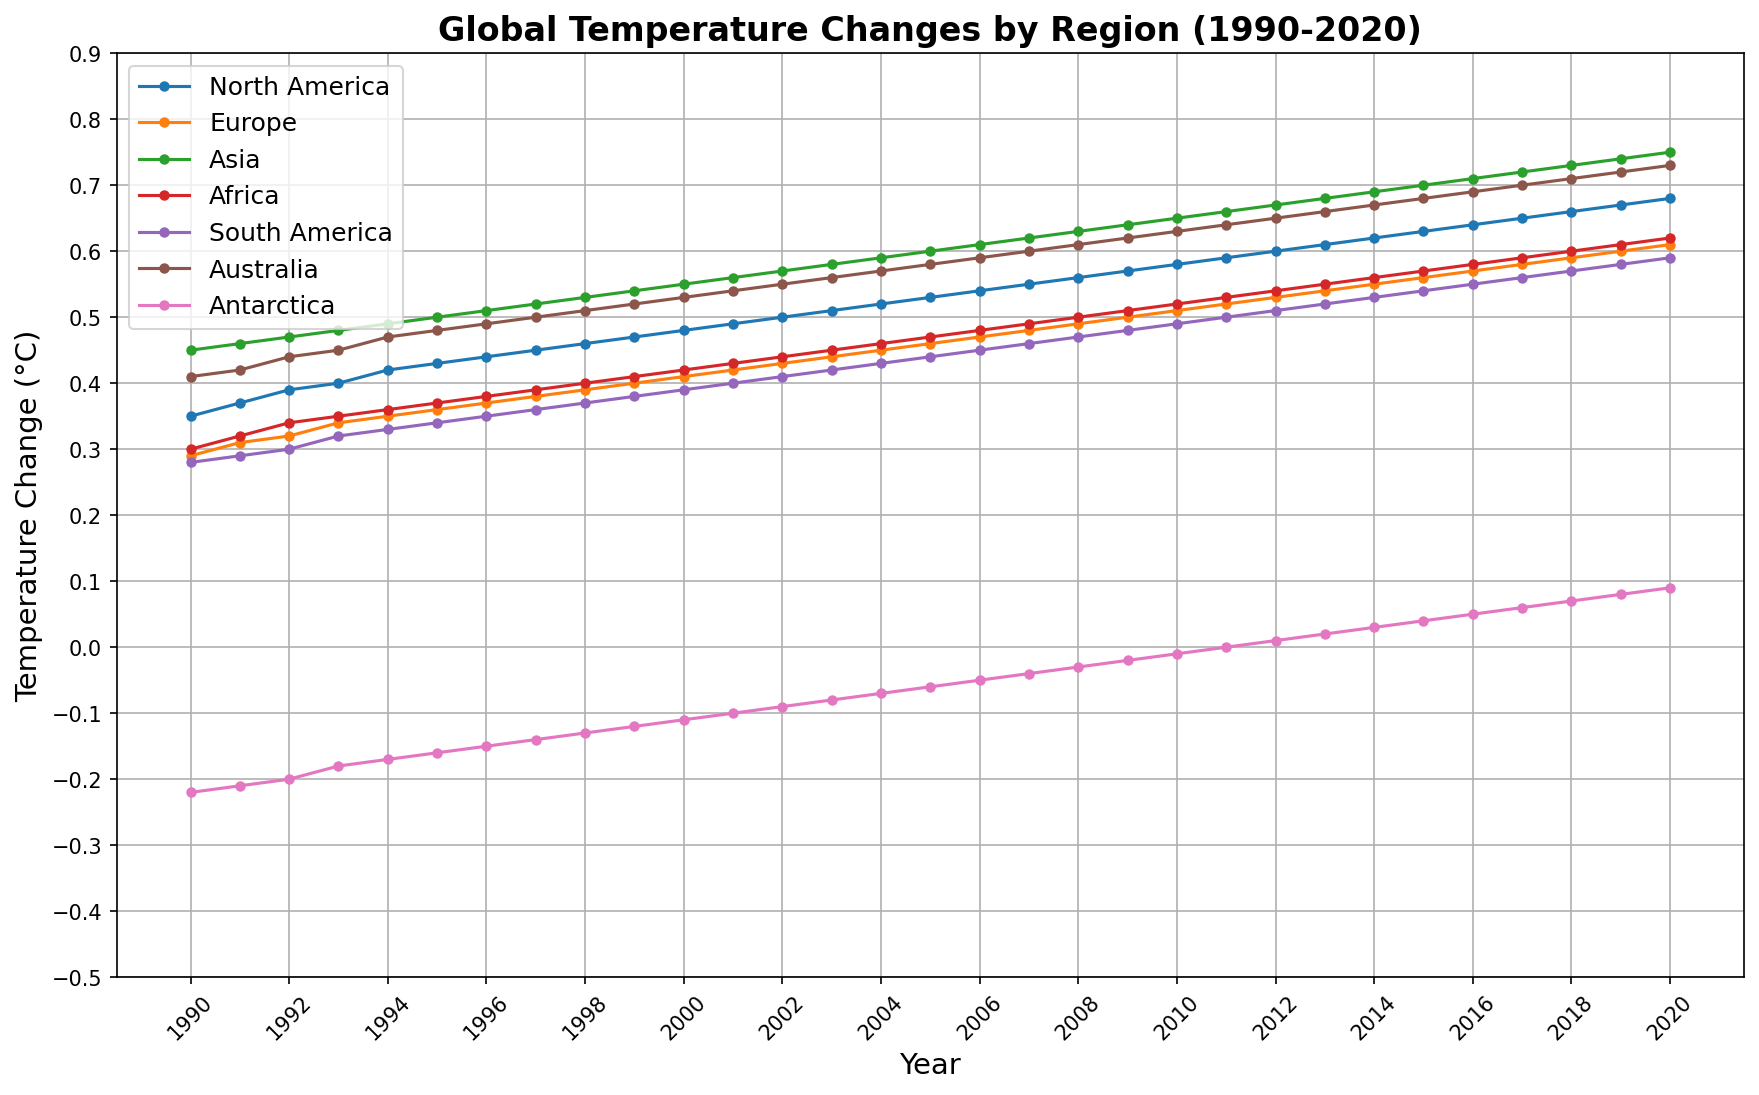What region experienced the greatest temperature change in 2020? To determine the region with the greatest temperature change, observe the data points for each region in 2020. The region with the highest data point will represent the greatest temperature change. In the plot, Asia in 2020 has the highest temperature change at 0.75°C.
Answer: Asia Which regions had a negative temperature change in 1990? To find the regions with a negative temperature change in 1990, look for data points below the zero line for that year. In 1990, Antarctica shows a negative temperature change at -0.22°C.
Answer: Antarctica Which region saw the most consistent increase in temperature from 1990 to 2020? To identify the region with the most consistent increase, observe the trend lines for each region from 1990 to 2020. The region with a consistently upward trend is Asia, which shows a steady increase in temperature change over the years.
Answer: Asia What is the difference in temperature change between North America and Europe in 2000? To find the difference between North America and Europe's temperature changes in 2000, subtract Europe's value from North America's. North America's value is 0.48°C, and Europe's is 0.41°C. The difference is 0.48 - 0.41 = 0.07°C.
Answer: 0.07°C Which year did Antarctica show a positive temperature change for the first time? To find the first year Antarctica shows a positive temperature change, look at its data points from 1990 to 2020. Antarctica reaches a positive value for the first time in 2011 with a change of 0.00°C.
Answer: 2011 Calculate the average temperature change for South America from 1990 to 2000. To calculate the average temperature change for South America from 1990 to 2000, sum the values and divide by the number of years. Sum: 0.28+0.29+0.30+0.32+0.33+0.34+0.35+0.36+0.37+0.38+0.39 = 3.71. Divide by the number of years: 3.71/11 ≈ 0.34°C.
Answer: 0.34°C Which region had the smallest temperature change in 1998? To find the smallest temperature change in 1998, compare the data points for all regions. Antarctica shows the smallest change with a value of -0.13°C.
Answer: Antarctica Which year saw the largest increase in temperature change for Africa compared to the previous year? To determine the year with the largest increase, calculate the yearly differences for Africa's temperature changes and find the maximum. The largest increase appears between 2007 (0.49°C) and 2008 (0.50°C), equal to 0.01°C.
Answer: 2008 In what year did Australia's temperature change exceed that of North America, and by how much? To determine when Australia's temperature change exceeded North America's, compare the data points year by year. Australia's temperature change first exceeds North America's in 1999. In 1999: Australia 0.52°C, North America 0.47°C. The difference is 0.52 - 0.47 = 0.05°C.
Answer: 1999, 0.05°C 